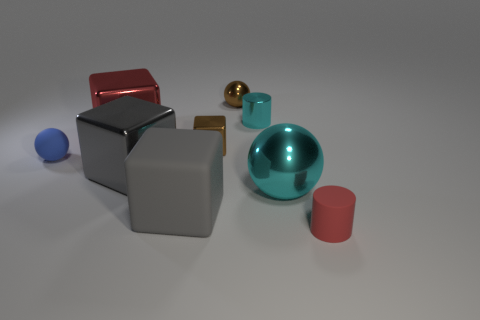How big is the shiny sphere that is in front of the metallic object behind the small cyan thing?
Give a very brief answer. Large. Are there an equal number of tiny blocks left of the small red rubber object and big red shiny objects that are behind the brown sphere?
Your answer should be very brief. No. What color is the other tiny object that is the same shape as the small red matte object?
Your response must be concise. Cyan. How many cylinders have the same color as the tiny rubber sphere?
Offer a very short reply. 0. There is a red thing left of the large cyan metallic object; is its shape the same as the large gray rubber object?
Offer a very short reply. Yes. There is a cyan shiny object in front of the ball that is on the left side of the tiny sphere that is behind the red block; what is its shape?
Ensure brevity in your answer.  Sphere. What size is the cyan shiny cylinder?
Give a very brief answer. Small. What is the color of the tiny block that is the same material as the small cyan cylinder?
Provide a succinct answer. Brown. What number of tiny cyan things are the same material as the brown sphere?
Provide a short and direct response. 1. There is a large metallic sphere; does it have the same color as the tiny cylinder behind the brown cube?
Offer a very short reply. Yes. 